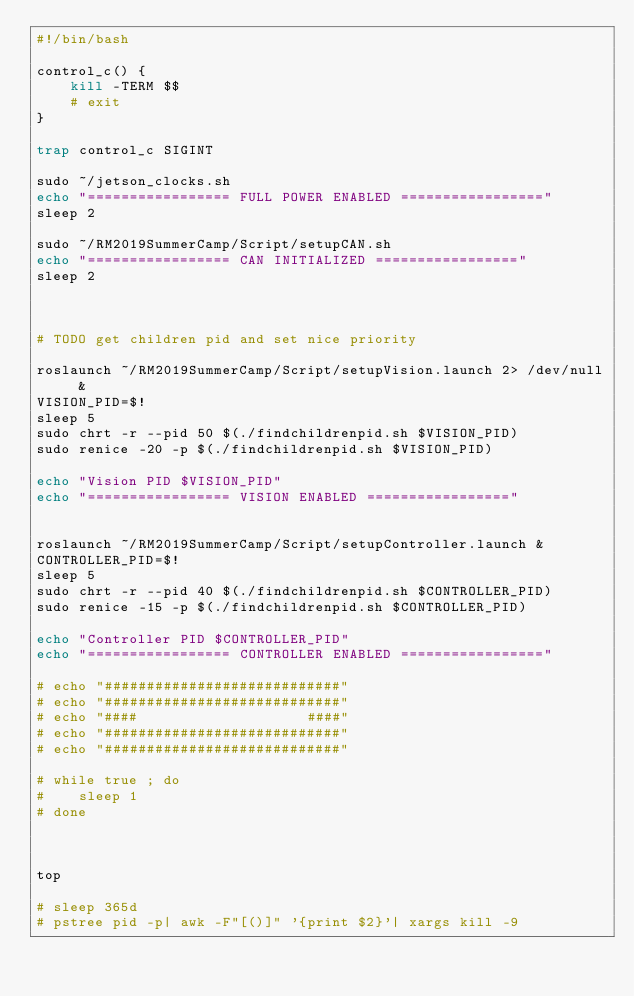Convert code to text. <code><loc_0><loc_0><loc_500><loc_500><_Bash_>#!/bin/bash

control_c() {
    kill -TERM $$
    # exit
}

trap control_c SIGINT

sudo ~/jetson_clocks.sh
echo "================= FULL POWER ENABLED ================="
sleep 2

sudo ~/RM2019SummerCamp/Script/setupCAN.sh
echo "================= CAN INITIALIZED ================="
sleep 2



# TODO get children pid and set nice priority

roslaunch ~/RM2019SummerCamp/Script/setupVision.launch 2> /dev/null &
VISION_PID=$!
sleep 5
sudo chrt -r --pid 50 $(./findchildrenpid.sh $VISION_PID)
sudo renice -20 -p $(./findchildrenpid.sh $VISION_PID)

echo "Vision PID $VISION_PID"
echo "================= VISION ENABLED ================="


roslaunch ~/RM2019SummerCamp/Script/setupController.launch &
CONTROLLER_PID=$!
sleep 5
sudo chrt -r --pid 40 $(./findchildrenpid.sh $CONTROLLER_PID)
sudo renice -15 -p $(./findchildrenpid.sh $CONTROLLER_PID)

echo "Controller PID $CONTROLLER_PID"
echo "================= CONTROLLER ENABLED ================="

# echo "############################"
# echo "############################"
# echo "####                    ####"
# echo "############################"
# echo "############################"

# while true ; do 
#    sleep 1
# done



top

# sleep 365d
# pstree pid -p| awk -F"[()]" '{print $2}'| xargs kill -9
</code> 